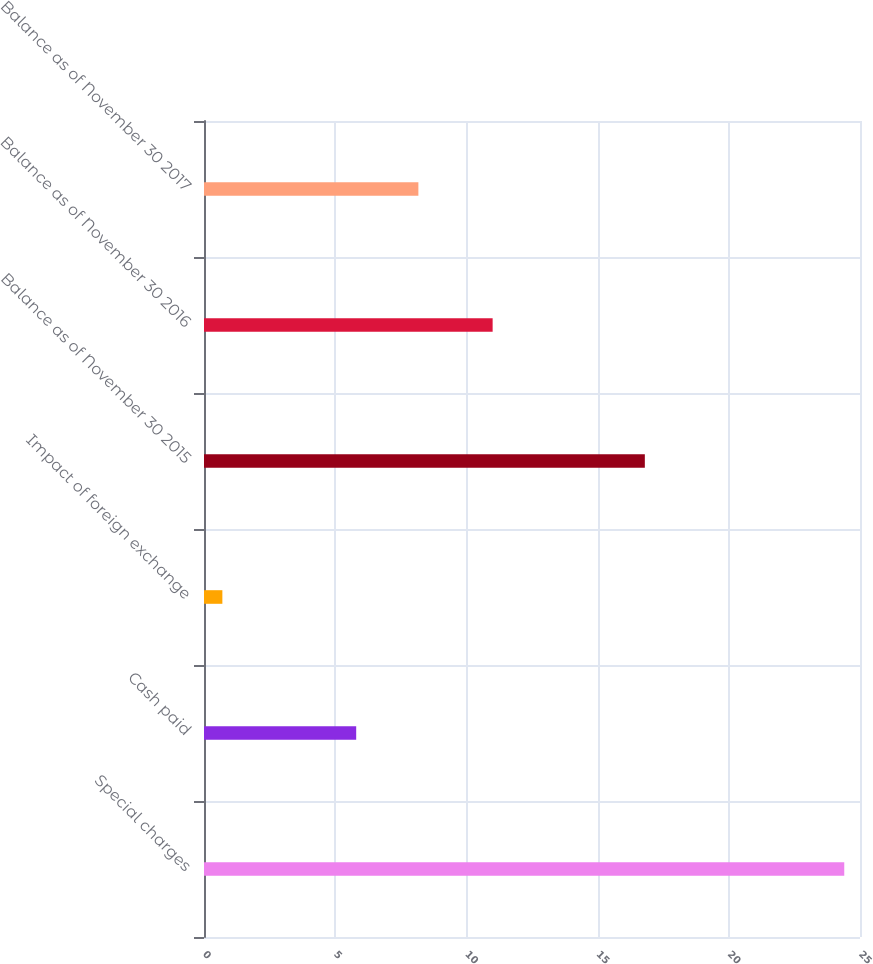Convert chart. <chart><loc_0><loc_0><loc_500><loc_500><bar_chart><fcel>Special charges<fcel>Cash paid<fcel>Impact of foreign exchange<fcel>Balance as of November 30 2015<fcel>Balance as of November 30 2016<fcel>Balance as of November 30 2017<nl><fcel>24.4<fcel>5.8<fcel>0.7<fcel>16.8<fcel>11<fcel>8.17<nl></chart> 